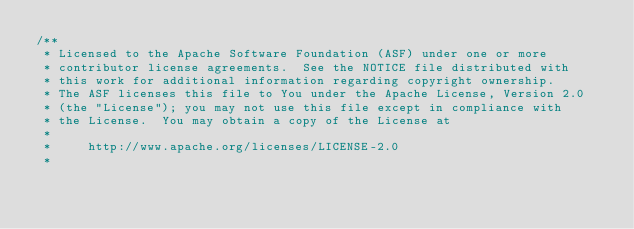Convert code to text. <code><loc_0><loc_0><loc_500><loc_500><_Java_>/**
 * Licensed to the Apache Software Foundation (ASF) under one or more
 * contributor license agreements.  See the NOTICE file distributed with
 * this work for additional information regarding copyright ownership.
 * The ASF licenses this file to You under the Apache License, Version 2.0
 * (the "License"); you may not use this file except in compliance with
 * the License.  You may obtain a copy of the License at
 *
 *     http://www.apache.org/licenses/LICENSE-2.0
 *</code> 